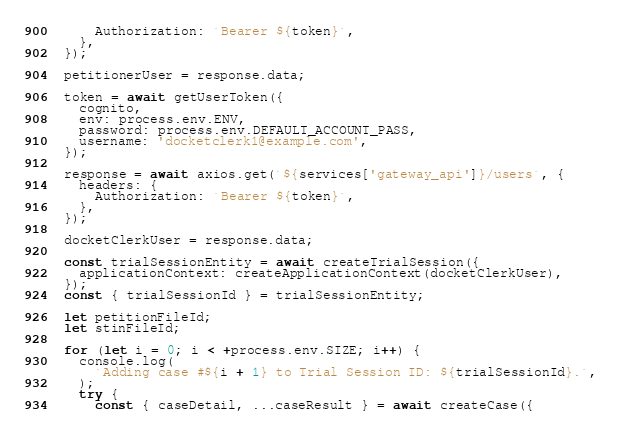Convert code to text. <code><loc_0><loc_0><loc_500><loc_500><_JavaScript_>      Authorization: `Bearer ${token}`,
    },
  });

  petitionerUser = response.data;

  token = await getUserToken({
    cognito,
    env: process.env.ENV,
    password: process.env.DEFAULT_ACCOUNT_PASS,
    username: 'docketclerk1@example.com',
  });

  response = await axios.get(`${services['gateway_api']}/users`, {
    headers: {
      Authorization: `Bearer ${token}`,
    },
  });

  docketClerkUser = response.data;

  const trialSessionEntity = await createTrialSession({
    applicationContext: createApplicationContext(docketClerkUser),
  });
  const { trialSessionId } = trialSessionEntity;

  let petitionFileId;
  let stinFileId;

  for (let i = 0; i < +process.env.SIZE; i++) {
    console.log(
      `Adding case #${i + 1} to Trial Session ID: ${trialSessionId}.`,
    );
    try {
      const { caseDetail, ...caseResult } = await createCase({</code> 